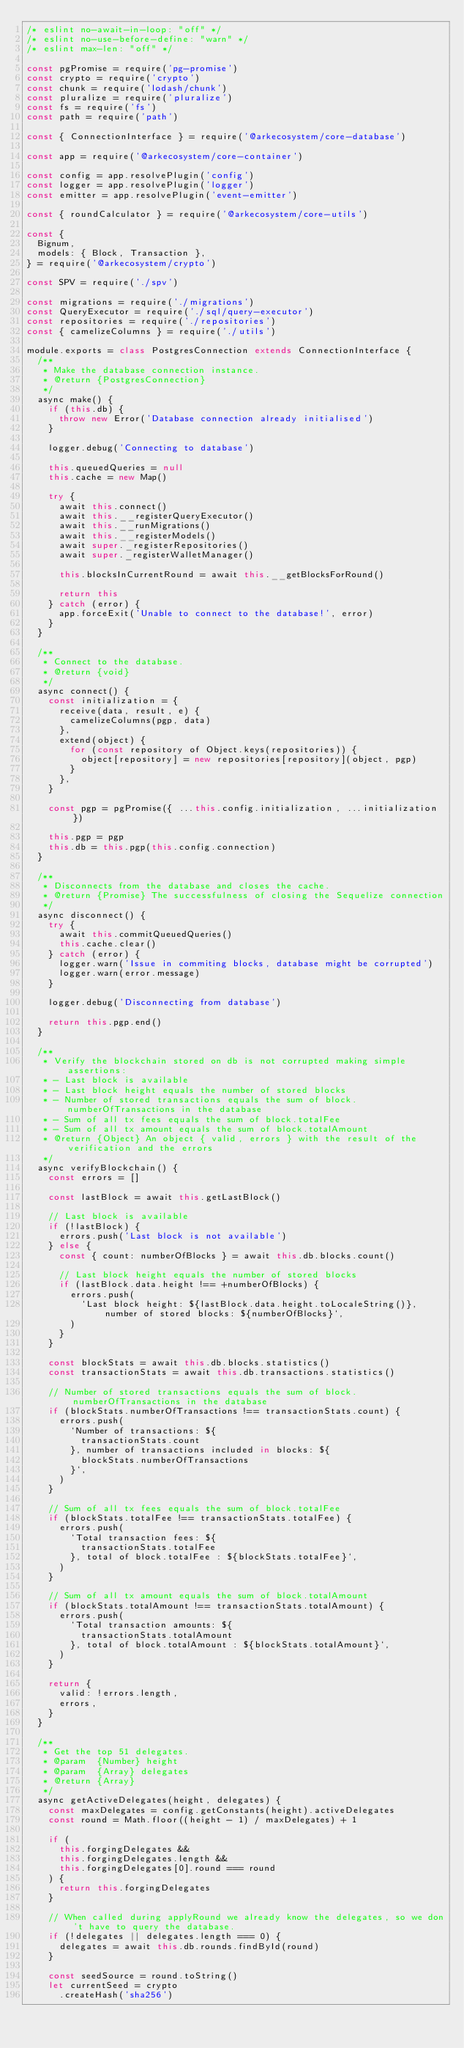Convert code to text. <code><loc_0><loc_0><loc_500><loc_500><_JavaScript_>/* eslint no-await-in-loop: "off" */
/* eslint no-use-before-define: "warn" */
/* eslint max-len: "off" */

const pgPromise = require('pg-promise')
const crypto = require('crypto')
const chunk = require('lodash/chunk')
const pluralize = require('pluralize')
const fs = require('fs')
const path = require('path')

const { ConnectionInterface } = require('@arkecosystem/core-database')

const app = require('@arkecosystem/core-container')

const config = app.resolvePlugin('config')
const logger = app.resolvePlugin('logger')
const emitter = app.resolvePlugin('event-emitter')

const { roundCalculator } = require('@arkecosystem/core-utils')

const {
  Bignum,
  models: { Block, Transaction },
} = require('@arkecosystem/crypto')

const SPV = require('./spv')

const migrations = require('./migrations')
const QueryExecutor = require('./sql/query-executor')
const repositories = require('./repositories')
const { camelizeColumns } = require('./utils')

module.exports = class PostgresConnection extends ConnectionInterface {
  /**
   * Make the database connection instance.
   * @return {PostgresConnection}
   */
  async make() {
    if (this.db) {
      throw new Error('Database connection already initialised')
    }

    logger.debug('Connecting to database')

    this.queuedQueries = null
    this.cache = new Map()

    try {
      await this.connect()
      await this.__registerQueryExecutor()
      await this.__runMigrations()
      await this.__registerModels()
      await super._registerRepositories()
      await super._registerWalletManager()

      this.blocksInCurrentRound = await this.__getBlocksForRound()

      return this
    } catch (error) {
      app.forceExit('Unable to connect to the database!', error)
    }
  }

  /**
   * Connect to the database.
   * @return {void}
   */
  async connect() {
    const initialization = {
      receive(data, result, e) {
        camelizeColumns(pgp, data)
      },
      extend(object) {
        for (const repository of Object.keys(repositories)) {
          object[repository] = new repositories[repository](object, pgp)
        }
      },
    }

    const pgp = pgPromise({ ...this.config.initialization, ...initialization })

    this.pgp = pgp
    this.db = this.pgp(this.config.connection)
  }

  /**
   * Disconnects from the database and closes the cache.
   * @return {Promise} The successfulness of closing the Sequelize connection
   */
  async disconnect() {
    try {
      await this.commitQueuedQueries()
      this.cache.clear()
    } catch (error) {
      logger.warn('Issue in commiting blocks, database might be corrupted')
      logger.warn(error.message)
    }

    logger.debug('Disconnecting from database')

    return this.pgp.end()
  }

  /**
   * Verify the blockchain stored on db is not corrupted making simple assertions:
   * - Last block is available
   * - Last block height equals the number of stored blocks
   * - Number of stored transactions equals the sum of block.numberOfTransactions in the database
   * - Sum of all tx fees equals the sum of block.totalFee
   * - Sum of all tx amount equals the sum of block.totalAmount
   * @return {Object} An object { valid, errors } with the result of the verification and the errors
   */
  async verifyBlockchain() {
    const errors = []

    const lastBlock = await this.getLastBlock()

    // Last block is available
    if (!lastBlock) {
      errors.push('Last block is not available')
    } else {
      const { count: numberOfBlocks } = await this.db.blocks.count()

      // Last block height equals the number of stored blocks
      if (lastBlock.data.height !== +numberOfBlocks) {
        errors.push(
          `Last block height: ${lastBlock.data.height.toLocaleString()}, number of stored blocks: ${numberOfBlocks}`,
        )
      }
    }

    const blockStats = await this.db.blocks.statistics()
    const transactionStats = await this.db.transactions.statistics()

    // Number of stored transactions equals the sum of block.numberOfTransactions in the database
    if (blockStats.numberOfTransactions !== transactionStats.count) {
      errors.push(
        `Number of transactions: ${
          transactionStats.count
        }, number of transactions included in blocks: ${
          blockStats.numberOfTransactions
        }`,
      )
    }

    // Sum of all tx fees equals the sum of block.totalFee
    if (blockStats.totalFee !== transactionStats.totalFee) {
      errors.push(
        `Total transaction fees: ${
          transactionStats.totalFee
        }, total of block.totalFee : ${blockStats.totalFee}`,
      )
    }

    // Sum of all tx amount equals the sum of block.totalAmount
    if (blockStats.totalAmount !== transactionStats.totalAmount) {
      errors.push(
        `Total transaction amounts: ${
          transactionStats.totalAmount
        }, total of block.totalAmount : ${blockStats.totalAmount}`,
      )
    }

    return {
      valid: !errors.length,
      errors,
    }
  }

  /**
   * Get the top 51 delegates.
   * @param  {Number} height
   * @param  {Array} delegates
   * @return {Array}
   */
  async getActiveDelegates(height, delegates) {
    const maxDelegates = config.getConstants(height).activeDelegates
    const round = Math.floor((height - 1) / maxDelegates) + 1

    if (
      this.forgingDelegates &&
      this.forgingDelegates.length &&
      this.forgingDelegates[0].round === round
    ) {
      return this.forgingDelegates
    }

    // When called during applyRound we already know the delegates, so we don't have to query the database.
    if (!delegates || delegates.length === 0) {
      delegates = await this.db.rounds.findById(round)
    }

    const seedSource = round.toString()
    let currentSeed = crypto
      .createHash('sha256')</code> 